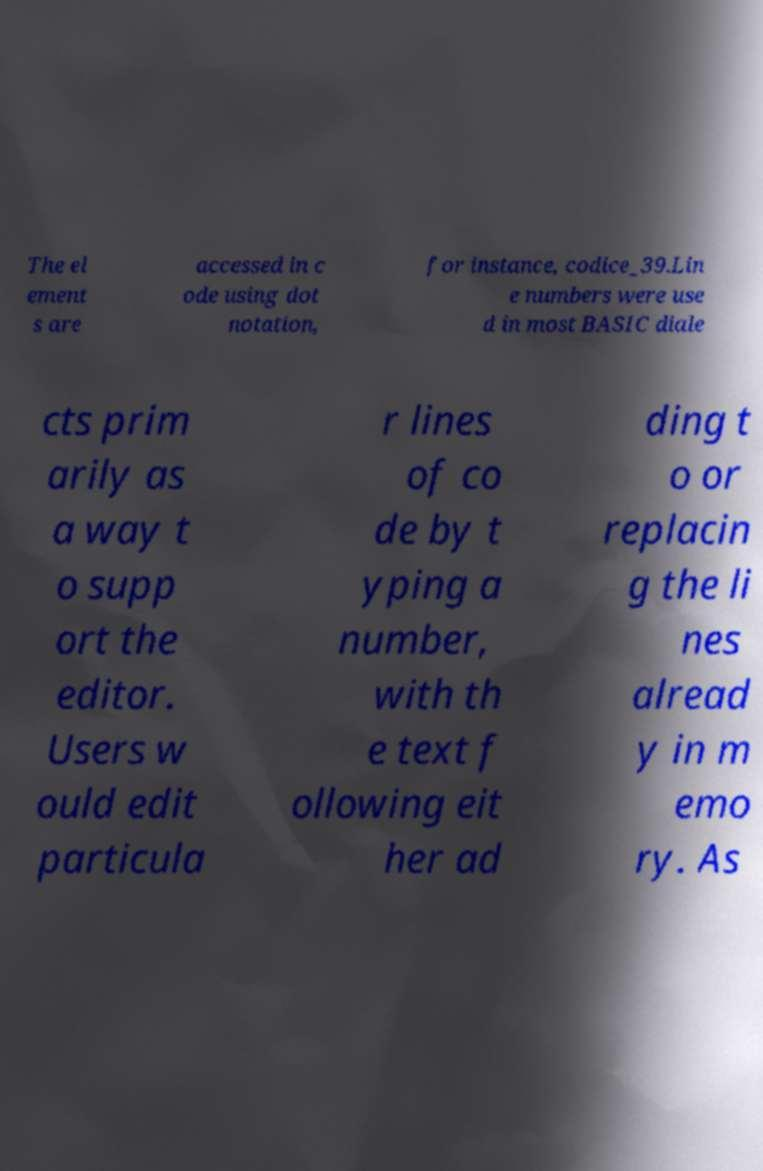Can you accurately transcribe the text from the provided image for me? The el ement s are accessed in c ode using dot notation, for instance, codice_39.Lin e numbers were use d in most BASIC diale cts prim arily as a way t o supp ort the editor. Users w ould edit particula r lines of co de by t yping a number, with th e text f ollowing eit her ad ding t o or replacin g the li nes alread y in m emo ry. As 